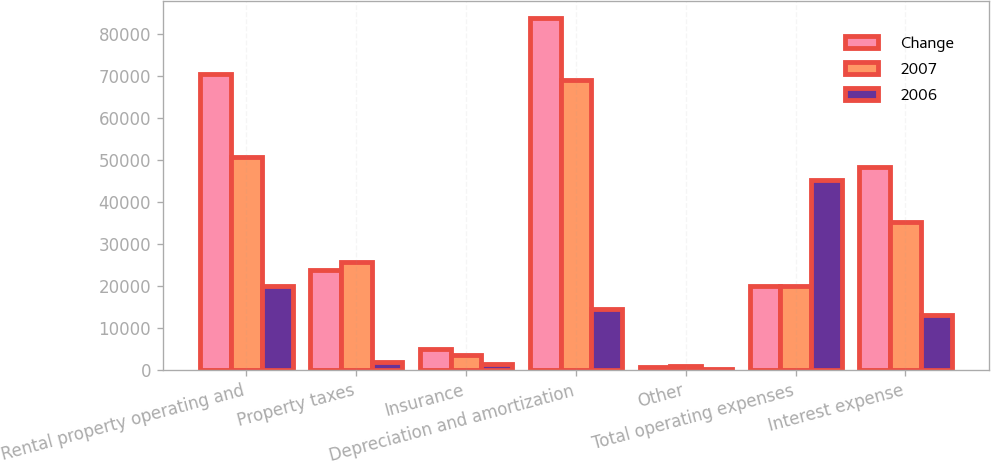Convert chart. <chart><loc_0><loc_0><loc_500><loc_500><stacked_bar_chart><ecel><fcel>Rental property operating and<fcel>Property taxes<fcel>Insurance<fcel>Depreciation and amortization<fcel>Other<fcel>Total operating expenses<fcel>Interest expense<nl><fcel>Change<fcel>70657<fcel>23878<fcel>5043<fcel>83816<fcel>776<fcel>19979<fcel>48470<nl><fcel>2007<fcel>50678<fcel>25698<fcel>3570<fcel>69243<fcel>932<fcel>19979<fcel>35327<nl><fcel>2006<fcel>19979<fcel>1820<fcel>1473<fcel>14573<fcel>156<fcel>45208<fcel>13143<nl></chart> 